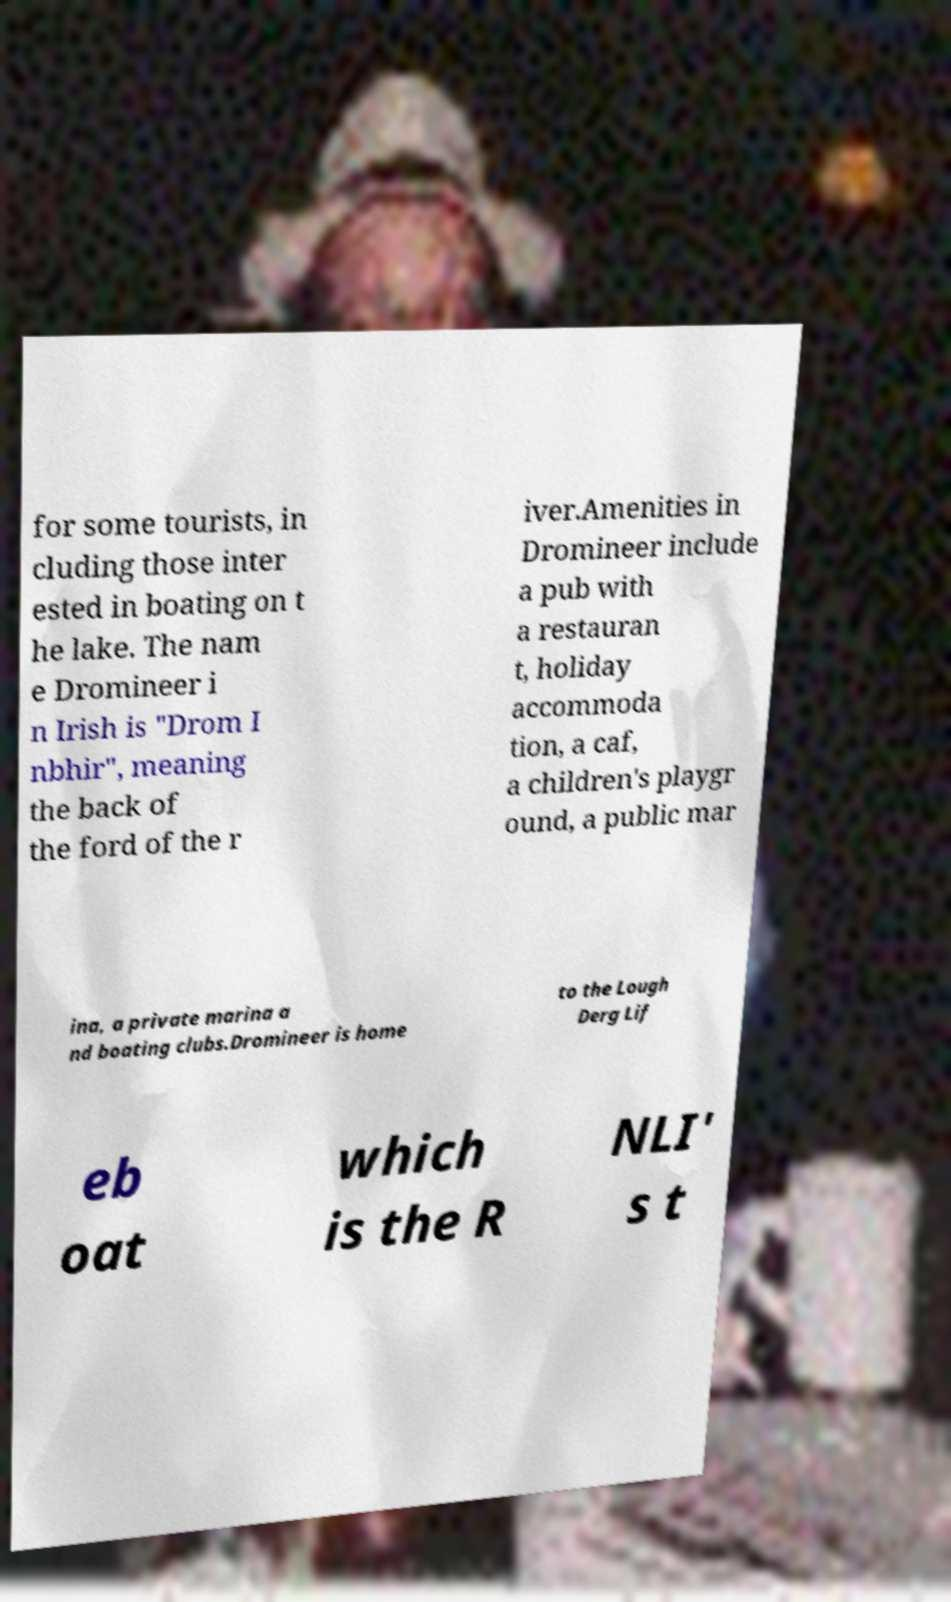For documentation purposes, I need the text within this image transcribed. Could you provide that? for some tourists, in cluding those inter ested in boating on t he lake. The nam e Dromineer i n Irish is "Drom I nbhir", meaning the back of the ford of the r iver.Amenities in Dromineer include a pub with a restauran t, holiday accommoda tion, a caf, a children's playgr ound, a public mar ina, a private marina a nd boating clubs.Dromineer is home to the Lough Derg Lif eb oat which is the R NLI' s t 